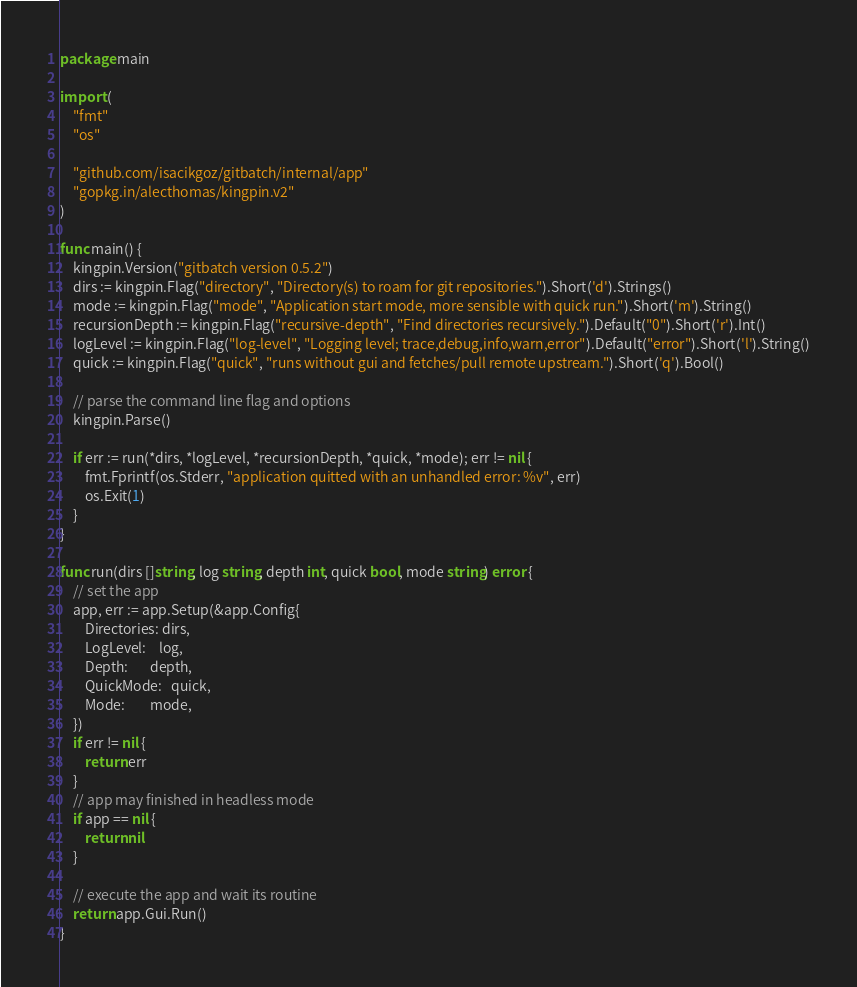Convert code to text. <code><loc_0><loc_0><loc_500><loc_500><_Go_>package main

import (
	"fmt"
	"os"

	"github.com/isacikgoz/gitbatch/internal/app"
	"gopkg.in/alecthomas/kingpin.v2"
)

func main() {
	kingpin.Version("gitbatch version 0.5.2")
	dirs := kingpin.Flag("directory", "Directory(s) to roam for git repositories.").Short('d').Strings()
	mode := kingpin.Flag("mode", "Application start mode, more sensible with quick run.").Short('m').String()
	recursionDepth := kingpin.Flag("recursive-depth", "Find directories recursively.").Default("0").Short('r').Int()
	logLevel := kingpin.Flag("log-level", "Logging level; trace,debug,info,warn,error").Default("error").Short('l').String()
	quick := kingpin.Flag("quick", "runs without gui and fetches/pull remote upstream.").Short('q').Bool()

	// parse the command line flag and options
	kingpin.Parse()

	if err := run(*dirs, *logLevel, *recursionDepth, *quick, *mode); err != nil {
		fmt.Fprintf(os.Stderr, "application quitted with an unhandled error: %v", err)
		os.Exit(1)
	}
}

func run(dirs []string, log string, depth int, quick bool, mode string) error {
	// set the app
	app, err := app.Setup(&app.Config{
		Directories: dirs,
		LogLevel:    log,
		Depth:       depth,
		QuickMode:   quick,
		Mode:        mode,
	})
	if err != nil {
		return err
	}
	// app may finished in headless mode
	if app == nil {
		return nil
	}

	// execute the app and wait its routine
	return app.Gui.Run()
}
</code> 